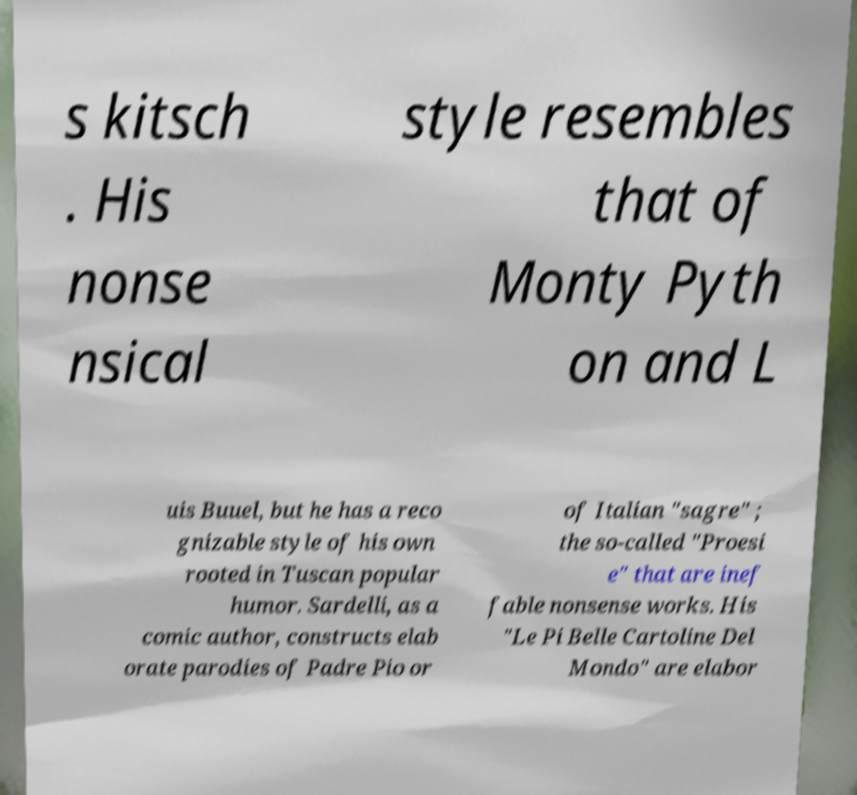Please identify and transcribe the text found in this image. s kitsch . His nonse nsical style resembles that of Monty Pyth on and L uis Buuel, but he has a reco gnizable style of his own rooted in Tuscan popular humor. Sardelli, as a comic author, constructs elab orate parodies of Padre Pio or of Italian "sagre" ; the so-called "Proesi e" that are inef fable nonsense works. His "Le Pi Belle Cartoline Del Mondo" are elabor 